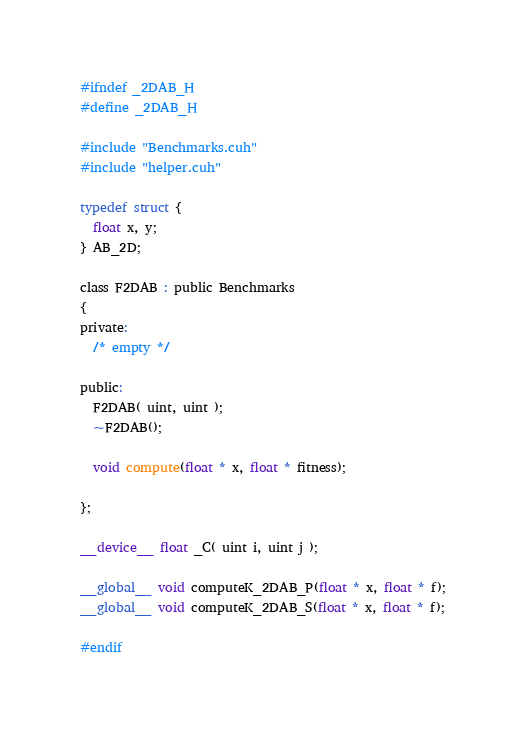<code> <loc_0><loc_0><loc_500><loc_500><_Cuda_>#ifndef _2DAB_H
#define _2DAB_H

#include "Benchmarks.cuh"
#include "helper.cuh"

typedef struct {
  float x, y;
} AB_2D;

class F2DAB : public Benchmarks
{
private:
  /* empty */

public:
  F2DAB( uint, uint );
  ~F2DAB();

  void compute(float * x, float * fitness);

};

__device__ float _C( uint i, uint j );

__global__ void computeK_2DAB_P(float * x, float * f);
__global__ void computeK_2DAB_S(float * x, float * f);

#endif
</code> 